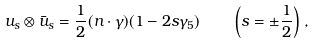<formula> <loc_0><loc_0><loc_500><loc_500>u _ { s } \otimes \bar { u } _ { s } = \frac { 1 } { 2 } ( n \cdot \gamma ) ( 1 - 2 s \gamma _ { 5 } ) \quad \left ( s = \pm \frac { 1 } { 2 } \right ) \, ,</formula> 